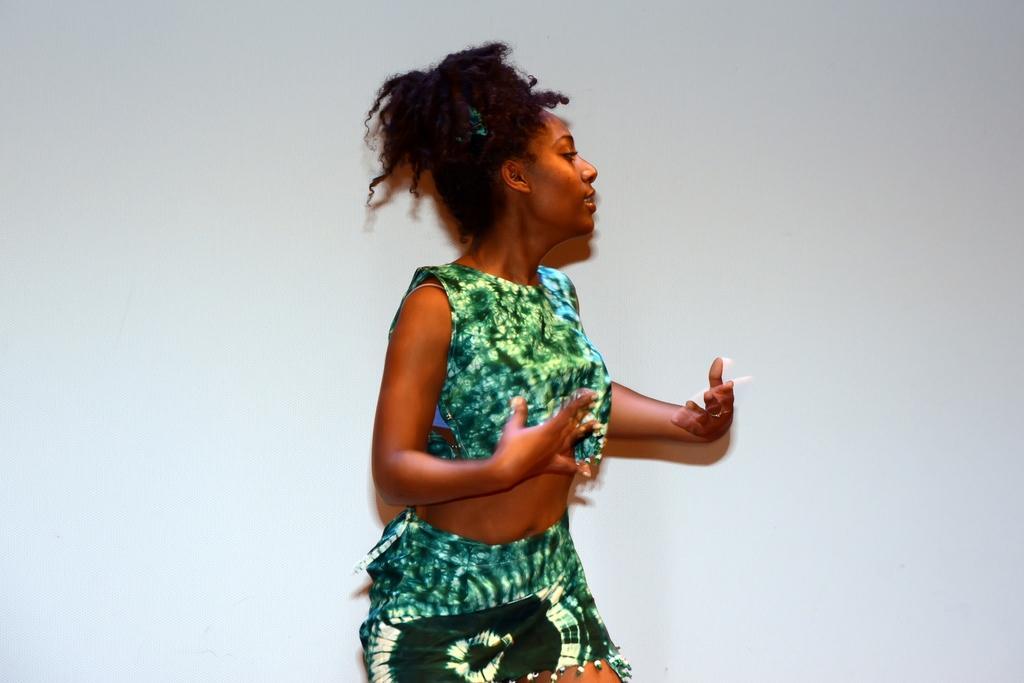Can you describe this image briefly? In this image we can see a woman wearing a dress is stunning. In the background, we can see the wall. 